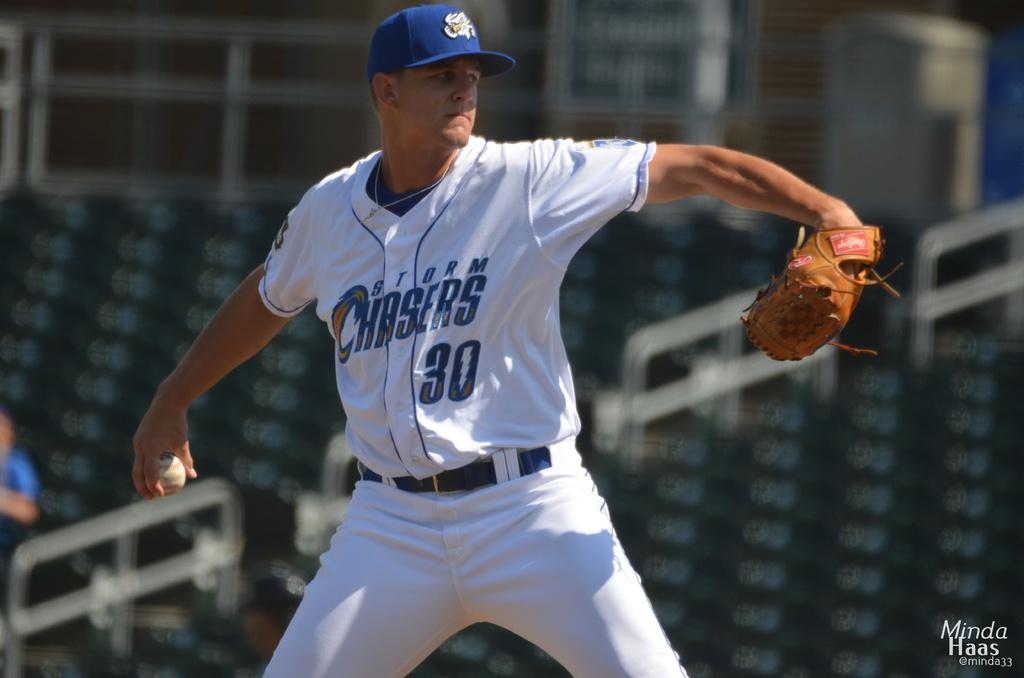<image>
Provide a brief description of the given image. A baseball player with a Storm Chasers jersey on throws a ball. 